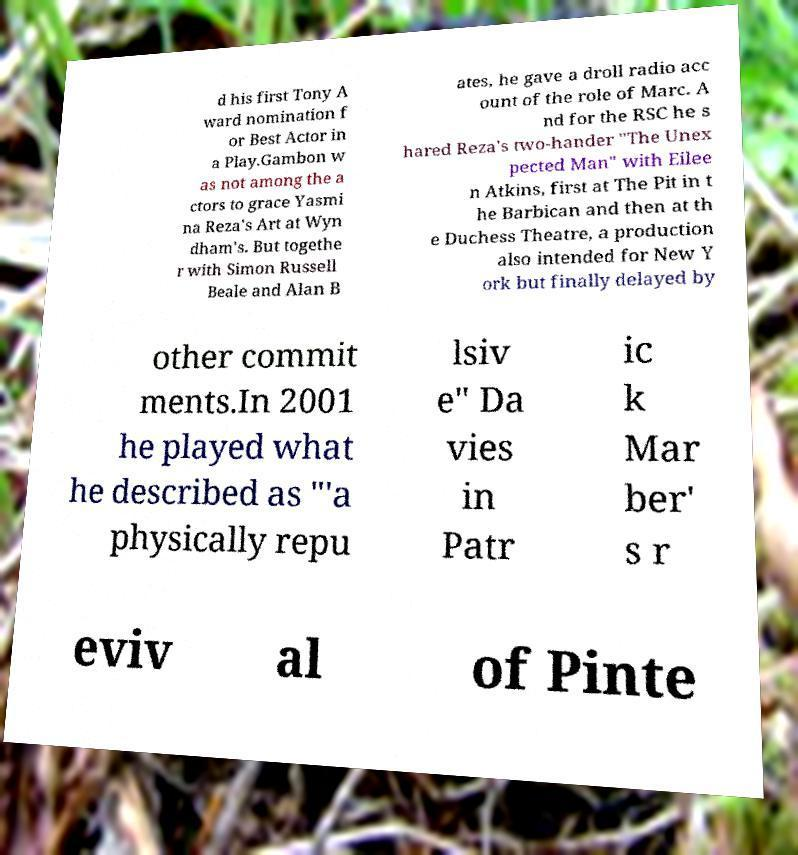Please identify and transcribe the text found in this image. d his first Tony A ward nomination f or Best Actor in a Play.Gambon w as not among the a ctors to grace Yasmi na Reza's Art at Wyn dham's. But togethe r with Simon Russell Beale and Alan B ates, he gave a droll radio acc ount of the role of Marc. A nd for the RSC he s hared Reza's two-hander "The Unex pected Man" with Eilee n Atkins, first at The Pit in t he Barbican and then at th e Duchess Theatre, a production also intended for New Y ork but finally delayed by other commit ments.In 2001 he played what he described as "'a physically repu lsiv e" Da vies in Patr ic k Mar ber' s r eviv al of Pinte 